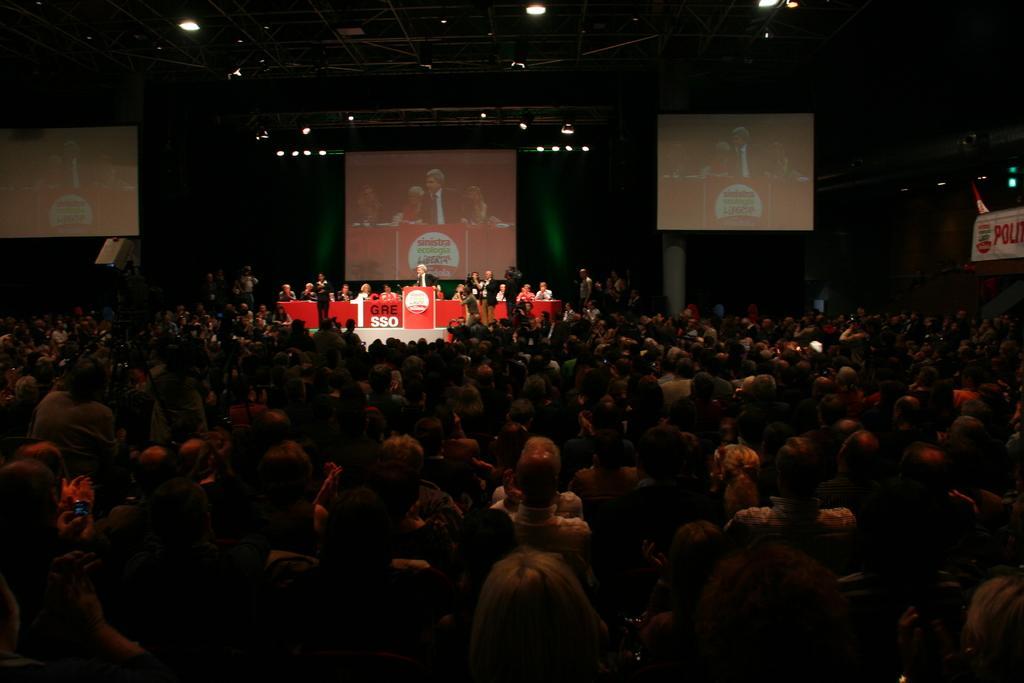Could you give a brief overview of what you see in this image? In this image there are group of persons sitting, there are persons standing, there is a podium, there is text on the podium, there are screens, there is a board towards the right of the image, there is text on the board, there is a flag, there is the roof towards the top of the image, there are lights, there is a pillar. 